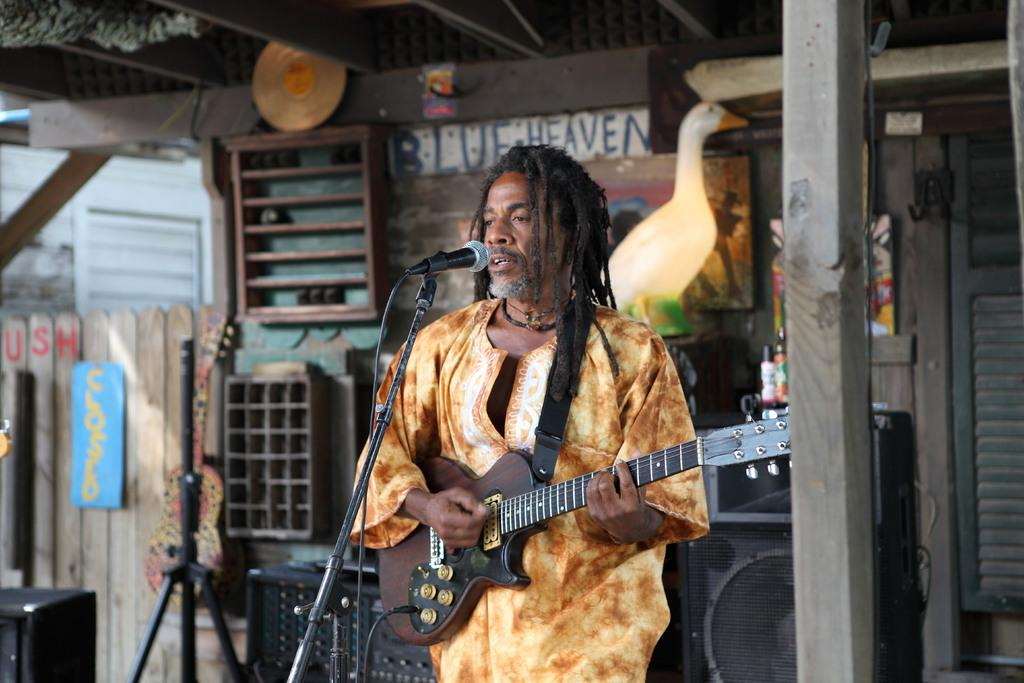Who is the main subject in the image? There is a man in the image. What is the man doing in the image? The man is playing a guitar and standing in front of a mic and stand. What can be seen in the background of the image? There is a wall and a pillar in the background of the image. Can you see an airplane flying in the background of the image? No, there is no airplane visible in the image. What type of liquid is being used by the man in the image? There is no liquid present in the image; the man is playing a guitar and standing in front of a mic and stand. 